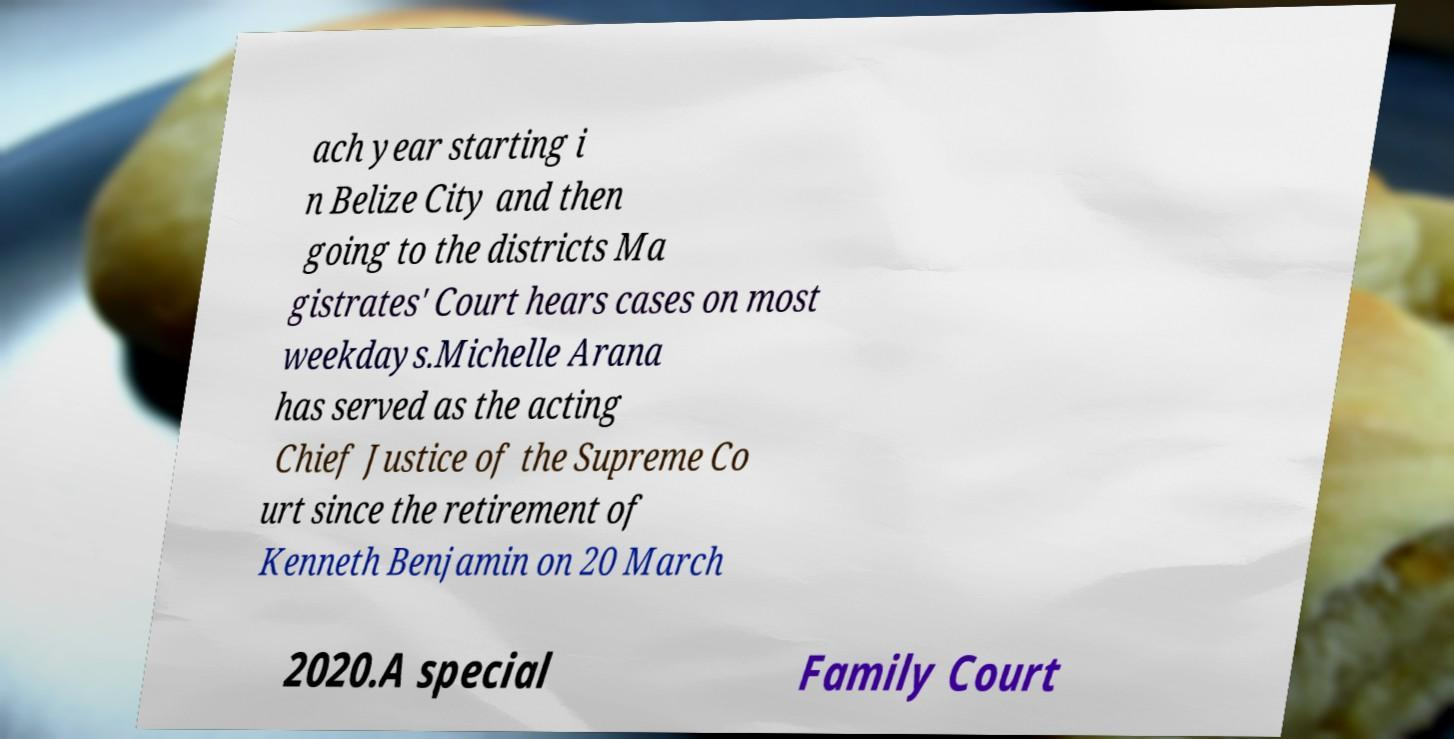There's text embedded in this image that I need extracted. Can you transcribe it verbatim? ach year starting i n Belize City and then going to the districts Ma gistrates' Court hears cases on most weekdays.Michelle Arana has served as the acting Chief Justice of the Supreme Co urt since the retirement of Kenneth Benjamin on 20 March 2020.A special Family Court 